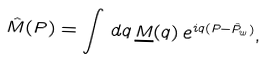Convert formula to latex. <formula><loc_0><loc_0><loc_500><loc_500>\hat { M } ( P ) = \int \, d q \, \underline { M } ( q ) \, e ^ { i q ( P - \hat { P } _ { w } ) } ,</formula> 